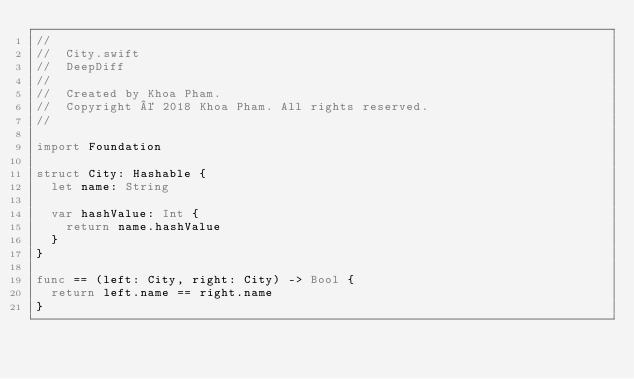<code> <loc_0><loc_0><loc_500><loc_500><_Swift_>//
//  City.swift
//  DeepDiff
//
//  Created by Khoa Pham.
//  Copyright © 2018 Khoa Pham. All rights reserved.
//

import Foundation

struct City: Hashable {
  let name: String

  var hashValue: Int {
    return name.hashValue
  }
}

func == (left: City, right: City) -> Bool {
  return left.name == right.name
}

</code> 